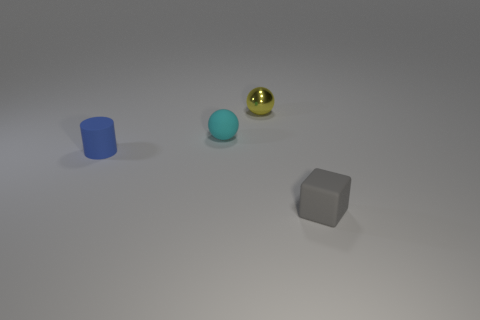Is there any other thing that has the same material as the yellow object?
Ensure brevity in your answer.  No. What number of tiny cyan spheres have the same material as the tiny gray cube?
Your answer should be very brief. 1. There is a cylinder that is the same material as the block; what color is it?
Ensure brevity in your answer.  Blue. Does the ball left of the yellow thing have the same size as the tiny gray object?
Keep it short and to the point. Yes. The rubber object that is the same shape as the metallic object is what color?
Provide a succinct answer. Cyan. The tiny yellow thing behind the matte thing that is behind the small matte object that is on the left side of the cyan matte sphere is what shape?
Make the answer very short. Sphere. Is the small blue rubber thing the same shape as the tiny yellow object?
Offer a terse response. No. The small thing right of the sphere that is on the right side of the rubber ball is what shape?
Ensure brevity in your answer.  Cube. Are any large things visible?
Your answer should be compact. No. What number of tiny gray matte things are in front of the object behind the matte object that is behind the tiny blue matte cylinder?
Your response must be concise. 1. 